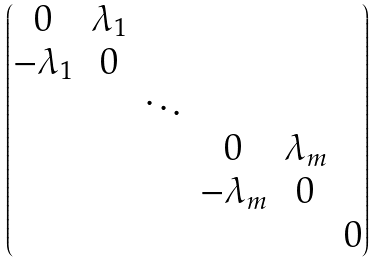Convert formula to latex. <formula><loc_0><loc_0><loc_500><loc_500>\begin{pmatrix} 0 & \lambda _ { 1 } \\ - \lambda _ { 1 } & 0 \\ & & \ddots \\ & & & 0 & \lambda _ { m } \\ & & & - \lambda _ { m } & 0 \\ & & & & & 0 \end{pmatrix}</formula> 